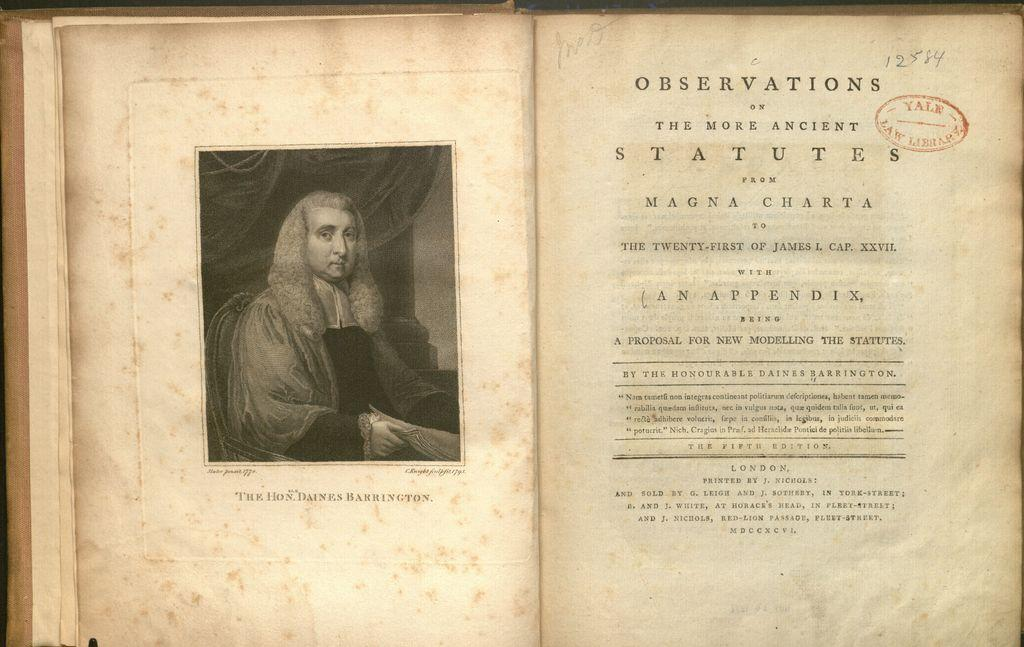<image>
Provide a brief description of the given image. An old book opened with the title of Observations on it. 